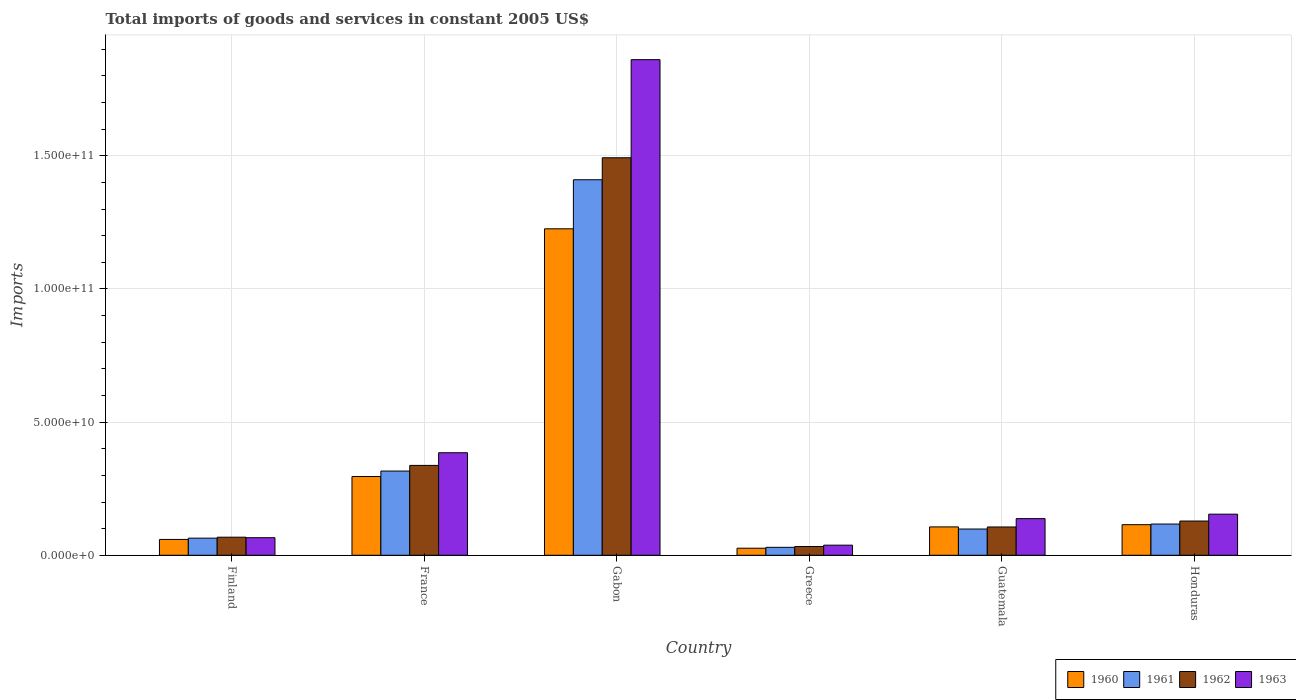How many bars are there on the 3rd tick from the right?
Keep it short and to the point. 4. What is the total imports of goods and services in 1961 in Finland?
Make the answer very short. 6.43e+09. Across all countries, what is the maximum total imports of goods and services in 1961?
Provide a succinct answer. 1.41e+11. Across all countries, what is the minimum total imports of goods and services in 1961?
Provide a succinct answer. 2.99e+09. In which country was the total imports of goods and services in 1961 maximum?
Give a very brief answer. Gabon. In which country was the total imports of goods and services in 1962 minimum?
Your answer should be compact. Greece. What is the total total imports of goods and services in 1960 in the graph?
Offer a terse response. 1.83e+11. What is the difference between the total imports of goods and services in 1963 in France and that in Honduras?
Ensure brevity in your answer.  2.31e+1. What is the difference between the total imports of goods and services in 1962 in Honduras and the total imports of goods and services in 1961 in France?
Your answer should be compact. -1.88e+1. What is the average total imports of goods and services in 1960 per country?
Make the answer very short. 3.05e+1. What is the difference between the total imports of goods and services of/in 1960 and total imports of goods and services of/in 1962 in Gabon?
Provide a short and direct response. -2.67e+1. In how many countries, is the total imports of goods and services in 1960 greater than 90000000000 US$?
Make the answer very short. 1. What is the ratio of the total imports of goods and services in 1962 in Guatemala to that in Honduras?
Ensure brevity in your answer.  0.83. Is the difference between the total imports of goods and services in 1960 in Gabon and Honduras greater than the difference between the total imports of goods and services in 1962 in Gabon and Honduras?
Offer a terse response. No. What is the difference between the highest and the second highest total imports of goods and services in 1963?
Offer a terse response. -2.31e+1. What is the difference between the highest and the lowest total imports of goods and services in 1960?
Give a very brief answer. 1.20e+11. In how many countries, is the total imports of goods and services in 1960 greater than the average total imports of goods and services in 1960 taken over all countries?
Ensure brevity in your answer.  1. Is the sum of the total imports of goods and services in 1961 in France and Honduras greater than the maximum total imports of goods and services in 1962 across all countries?
Provide a succinct answer. No. What does the 4th bar from the right in Guatemala represents?
Give a very brief answer. 1960. Is it the case that in every country, the sum of the total imports of goods and services in 1962 and total imports of goods and services in 1960 is greater than the total imports of goods and services in 1961?
Offer a terse response. Yes. What is the difference between two consecutive major ticks on the Y-axis?
Offer a very short reply. 5.00e+1. Are the values on the major ticks of Y-axis written in scientific E-notation?
Keep it short and to the point. Yes. Does the graph contain grids?
Your answer should be very brief. Yes. How many legend labels are there?
Your answer should be compact. 4. How are the legend labels stacked?
Provide a short and direct response. Horizontal. What is the title of the graph?
Your answer should be very brief. Total imports of goods and services in constant 2005 US$. What is the label or title of the X-axis?
Make the answer very short. Country. What is the label or title of the Y-axis?
Your answer should be very brief. Imports. What is the Imports in 1960 in Finland?
Ensure brevity in your answer.  5.95e+09. What is the Imports in 1961 in Finland?
Keep it short and to the point. 6.43e+09. What is the Imports of 1962 in Finland?
Provide a short and direct response. 6.79e+09. What is the Imports in 1963 in Finland?
Your answer should be very brief. 6.60e+09. What is the Imports in 1960 in France?
Keep it short and to the point. 2.96e+1. What is the Imports of 1961 in France?
Keep it short and to the point. 3.16e+1. What is the Imports of 1962 in France?
Provide a short and direct response. 3.37e+1. What is the Imports in 1963 in France?
Offer a very short reply. 3.85e+1. What is the Imports in 1960 in Gabon?
Your response must be concise. 1.23e+11. What is the Imports of 1961 in Gabon?
Provide a short and direct response. 1.41e+11. What is the Imports in 1962 in Gabon?
Offer a very short reply. 1.49e+11. What is the Imports of 1963 in Gabon?
Ensure brevity in your answer.  1.86e+11. What is the Imports of 1960 in Greece?
Offer a very short reply. 2.65e+09. What is the Imports in 1961 in Greece?
Your answer should be very brief. 2.99e+09. What is the Imports in 1962 in Greece?
Provide a short and direct response. 3.29e+09. What is the Imports of 1963 in Greece?
Ensure brevity in your answer.  3.80e+09. What is the Imports of 1960 in Guatemala?
Your answer should be very brief. 1.07e+1. What is the Imports of 1961 in Guatemala?
Make the answer very short. 9.86e+09. What is the Imports of 1962 in Guatemala?
Provide a succinct answer. 1.06e+1. What is the Imports of 1963 in Guatemala?
Offer a terse response. 1.38e+1. What is the Imports of 1960 in Honduras?
Ensure brevity in your answer.  1.15e+1. What is the Imports in 1961 in Honduras?
Ensure brevity in your answer.  1.17e+1. What is the Imports of 1962 in Honduras?
Offer a very short reply. 1.29e+1. What is the Imports in 1963 in Honduras?
Make the answer very short. 1.54e+1. Across all countries, what is the maximum Imports of 1960?
Your response must be concise. 1.23e+11. Across all countries, what is the maximum Imports of 1961?
Offer a terse response. 1.41e+11. Across all countries, what is the maximum Imports in 1962?
Give a very brief answer. 1.49e+11. Across all countries, what is the maximum Imports in 1963?
Make the answer very short. 1.86e+11. Across all countries, what is the minimum Imports in 1960?
Offer a very short reply. 2.65e+09. Across all countries, what is the minimum Imports in 1961?
Your answer should be compact. 2.99e+09. Across all countries, what is the minimum Imports of 1962?
Offer a terse response. 3.29e+09. Across all countries, what is the minimum Imports in 1963?
Provide a short and direct response. 3.80e+09. What is the total Imports of 1960 in the graph?
Provide a succinct answer. 1.83e+11. What is the total Imports of 1961 in the graph?
Offer a terse response. 2.04e+11. What is the total Imports in 1962 in the graph?
Your answer should be compact. 2.17e+11. What is the total Imports of 1963 in the graph?
Offer a terse response. 2.64e+11. What is the difference between the Imports in 1960 in Finland and that in France?
Your answer should be very brief. -2.36e+1. What is the difference between the Imports of 1961 in Finland and that in France?
Give a very brief answer. -2.52e+1. What is the difference between the Imports of 1962 in Finland and that in France?
Keep it short and to the point. -2.70e+1. What is the difference between the Imports of 1963 in Finland and that in France?
Provide a short and direct response. -3.19e+1. What is the difference between the Imports of 1960 in Finland and that in Gabon?
Offer a terse response. -1.17e+11. What is the difference between the Imports of 1961 in Finland and that in Gabon?
Your answer should be very brief. -1.35e+11. What is the difference between the Imports in 1962 in Finland and that in Gabon?
Your answer should be very brief. -1.42e+11. What is the difference between the Imports of 1963 in Finland and that in Gabon?
Provide a short and direct response. -1.79e+11. What is the difference between the Imports in 1960 in Finland and that in Greece?
Offer a terse response. 3.30e+09. What is the difference between the Imports of 1961 in Finland and that in Greece?
Offer a terse response. 3.44e+09. What is the difference between the Imports of 1962 in Finland and that in Greece?
Ensure brevity in your answer.  3.50e+09. What is the difference between the Imports in 1963 in Finland and that in Greece?
Make the answer very short. 2.80e+09. What is the difference between the Imports of 1960 in Finland and that in Guatemala?
Your answer should be very brief. -4.70e+09. What is the difference between the Imports of 1961 in Finland and that in Guatemala?
Give a very brief answer. -3.43e+09. What is the difference between the Imports of 1962 in Finland and that in Guatemala?
Make the answer very short. -3.84e+09. What is the difference between the Imports of 1963 in Finland and that in Guatemala?
Keep it short and to the point. -7.16e+09. What is the difference between the Imports in 1960 in Finland and that in Honduras?
Provide a succinct answer. -5.54e+09. What is the difference between the Imports of 1961 in Finland and that in Honduras?
Provide a succinct answer. -5.30e+09. What is the difference between the Imports of 1962 in Finland and that in Honduras?
Make the answer very short. -6.06e+09. What is the difference between the Imports in 1963 in Finland and that in Honduras?
Offer a very short reply. -8.84e+09. What is the difference between the Imports of 1960 in France and that in Gabon?
Keep it short and to the point. -9.30e+1. What is the difference between the Imports in 1961 in France and that in Gabon?
Make the answer very short. -1.09e+11. What is the difference between the Imports of 1962 in France and that in Gabon?
Make the answer very short. -1.16e+11. What is the difference between the Imports in 1963 in France and that in Gabon?
Offer a very short reply. -1.48e+11. What is the difference between the Imports of 1960 in France and that in Greece?
Offer a terse response. 2.69e+1. What is the difference between the Imports of 1961 in France and that in Greece?
Ensure brevity in your answer.  2.86e+1. What is the difference between the Imports in 1962 in France and that in Greece?
Your response must be concise. 3.05e+1. What is the difference between the Imports of 1963 in France and that in Greece?
Offer a very short reply. 3.47e+1. What is the difference between the Imports in 1960 in France and that in Guatemala?
Ensure brevity in your answer.  1.89e+1. What is the difference between the Imports of 1961 in France and that in Guatemala?
Keep it short and to the point. 2.18e+1. What is the difference between the Imports in 1962 in France and that in Guatemala?
Keep it short and to the point. 2.31e+1. What is the difference between the Imports of 1963 in France and that in Guatemala?
Your answer should be very brief. 2.47e+1. What is the difference between the Imports in 1960 in France and that in Honduras?
Your response must be concise. 1.81e+1. What is the difference between the Imports of 1961 in France and that in Honduras?
Provide a short and direct response. 1.99e+1. What is the difference between the Imports of 1962 in France and that in Honduras?
Give a very brief answer. 2.09e+1. What is the difference between the Imports in 1963 in France and that in Honduras?
Provide a succinct answer. 2.31e+1. What is the difference between the Imports of 1960 in Gabon and that in Greece?
Give a very brief answer. 1.20e+11. What is the difference between the Imports of 1961 in Gabon and that in Greece?
Provide a short and direct response. 1.38e+11. What is the difference between the Imports of 1962 in Gabon and that in Greece?
Ensure brevity in your answer.  1.46e+11. What is the difference between the Imports in 1963 in Gabon and that in Greece?
Provide a succinct answer. 1.82e+11. What is the difference between the Imports of 1960 in Gabon and that in Guatemala?
Your response must be concise. 1.12e+11. What is the difference between the Imports of 1961 in Gabon and that in Guatemala?
Your response must be concise. 1.31e+11. What is the difference between the Imports in 1962 in Gabon and that in Guatemala?
Provide a short and direct response. 1.39e+11. What is the difference between the Imports in 1963 in Gabon and that in Guatemala?
Offer a terse response. 1.72e+11. What is the difference between the Imports of 1960 in Gabon and that in Honduras?
Your answer should be compact. 1.11e+11. What is the difference between the Imports in 1961 in Gabon and that in Honduras?
Make the answer very short. 1.29e+11. What is the difference between the Imports in 1962 in Gabon and that in Honduras?
Give a very brief answer. 1.36e+11. What is the difference between the Imports of 1963 in Gabon and that in Honduras?
Give a very brief answer. 1.71e+11. What is the difference between the Imports in 1960 in Greece and that in Guatemala?
Offer a very short reply. -8.00e+09. What is the difference between the Imports of 1961 in Greece and that in Guatemala?
Make the answer very short. -6.87e+09. What is the difference between the Imports of 1962 in Greece and that in Guatemala?
Provide a succinct answer. -7.34e+09. What is the difference between the Imports of 1963 in Greece and that in Guatemala?
Your response must be concise. -9.96e+09. What is the difference between the Imports of 1960 in Greece and that in Honduras?
Give a very brief answer. -8.83e+09. What is the difference between the Imports in 1961 in Greece and that in Honduras?
Ensure brevity in your answer.  -8.74e+09. What is the difference between the Imports in 1962 in Greece and that in Honduras?
Your answer should be very brief. -9.56e+09. What is the difference between the Imports in 1963 in Greece and that in Honduras?
Offer a terse response. -1.16e+1. What is the difference between the Imports in 1960 in Guatemala and that in Honduras?
Your answer should be very brief. -8.33e+08. What is the difference between the Imports of 1961 in Guatemala and that in Honduras?
Offer a terse response. -1.87e+09. What is the difference between the Imports in 1962 in Guatemala and that in Honduras?
Ensure brevity in your answer.  -2.23e+09. What is the difference between the Imports in 1963 in Guatemala and that in Honduras?
Ensure brevity in your answer.  -1.68e+09. What is the difference between the Imports of 1960 in Finland and the Imports of 1961 in France?
Your answer should be compact. -2.57e+1. What is the difference between the Imports in 1960 in Finland and the Imports in 1962 in France?
Your answer should be very brief. -2.78e+1. What is the difference between the Imports of 1960 in Finland and the Imports of 1963 in France?
Keep it short and to the point. -3.25e+1. What is the difference between the Imports of 1961 in Finland and the Imports of 1962 in France?
Ensure brevity in your answer.  -2.73e+1. What is the difference between the Imports in 1961 in Finland and the Imports in 1963 in France?
Provide a succinct answer. -3.21e+1. What is the difference between the Imports of 1962 in Finland and the Imports of 1963 in France?
Provide a short and direct response. -3.17e+1. What is the difference between the Imports of 1960 in Finland and the Imports of 1961 in Gabon?
Give a very brief answer. -1.35e+11. What is the difference between the Imports in 1960 in Finland and the Imports in 1962 in Gabon?
Offer a terse response. -1.43e+11. What is the difference between the Imports in 1960 in Finland and the Imports in 1963 in Gabon?
Your answer should be compact. -1.80e+11. What is the difference between the Imports of 1961 in Finland and the Imports of 1962 in Gabon?
Give a very brief answer. -1.43e+11. What is the difference between the Imports in 1961 in Finland and the Imports in 1963 in Gabon?
Give a very brief answer. -1.80e+11. What is the difference between the Imports in 1962 in Finland and the Imports in 1963 in Gabon?
Your response must be concise. -1.79e+11. What is the difference between the Imports of 1960 in Finland and the Imports of 1961 in Greece?
Your response must be concise. 2.96e+09. What is the difference between the Imports in 1960 in Finland and the Imports in 1962 in Greece?
Give a very brief answer. 2.66e+09. What is the difference between the Imports of 1960 in Finland and the Imports of 1963 in Greece?
Provide a short and direct response. 2.15e+09. What is the difference between the Imports of 1961 in Finland and the Imports of 1962 in Greece?
Your response must be concise. 3.14e+09. What is the difference between the Imports of 1961 in Finland and the Imports of 1963 in Greece?
Ensure brevity in your answer.  2.63e+09. What is the difference between the Imports in 1962 in Finland and the Imports in 1963 in Greece?
Your response must be concise. 2.99e+09. What is the difference between the Imports of 1960 in Finland and the Imports of 1961 in Guatemala?
Your answer should be compact. -3.91e+09. What is the difference between the Imports in 1960 in Finland and the Imports in 1962 in Guatemala?
Provide a succinct answer. -4.68e+09. What is the difference between the Imports of 1960 in Finland and the Imports of 1963 in Guatemala?
Make the answer very short. -7.81e+09. What is the difference between the Imports of 1961 in Finland and the Imports of 1962 in Guatemala?
Your answer should be very brief. -4.20e+09. What is the difference between the Imports in 1961 in Finland and the Imports in 1963 in Guatemala?
Offer a terse response. -7.33e+09. What is the difference between the Imports of 1962 in Finland and the Imports of 1963 in Guatemala?
Your response must be concise. -6.97e+09. What is the difference between the Imports in 1960 in Finland and the Imports in 1961 in Honduras?
Give a very brief answer. -5.78e+09. What is the difference between the Imports in 1960 in Finland and the Imports in 1962 in Honduras?
Your answer should be compact. -6.90e+09. What is the difference between the Imports of 1960 in Finland and the Imports of 1963 in Honduras?
Your answer should be very brief. -9.49e+09. What is the difference between the Imports in 1961 in Finland and the Imports in 1962 in Honduras?
Keep it short and to the point. -6.42e+09. What is the difference between the Imports in 1961 in Finland and the Imports in 1963 in Honduras?
Provide a short and direct response. -9.01e+09. What is the difference between the Imports in 1962 in Finland and the Imports in 1963 in Honduras?
Ensure brevity in your answer.  -8.65e+09. What is the difference between the Imports of 1960 in France and the Imports of 1961 in Gabon?
Provide a succinct answer. -1.11e+11. What is the difference between the Imports of 1960 in France and the Imports of 1962 in Gabon?
Give a very brief answer. -1.20e+11. What is the difference between the Imports in 1960 in France and the Imports in 1963 in Gabon?
Provide a succinct answer. -1.57e+11. What is the difference between the Imports of 1961 in France and the Imports of 1962 in Gabon?
Keep it short and to the point. -1.18e+11. What is the difference between the Imports in 1961 in France and the Imports in 1963 in Gabon?
Keep it short and to the point. -1.54e+11. What is the difference between the Imports of 1962 in France and the Imports of 1963 in Gabon?
Your answer should be compact. -1.52e+11. What is the difference between the Imports in 1960 in France and the Imports in 1961 in Greece?
Your response must be concise. 2.66e+1. What is the difference between the Imports of 1960 in France and the Imports of 1962 in Greece?
Your response must be concise. 2.63e+1. What is the difference between the Imports of 1960 in France and the Imports of 1963 in Greece?
Offer a very short reply. 2.58e+1. What is the difference between the Imports of 1961 in France and the Imports of 1962 in Greece?
Your answer should be very brief. 2.83e+1. What is the difference between the Imports of 1961 in France and the Imports of 1963 in Greece?
Provide a succinct answer. 2.78e+1. What is the difference between the Imports in 1962 in France and the Imports in 1963 in Greece?
Ensure brevity in your answer.  2.99e+1. What is the difference between the Imports of 1960 in France and the Imports of 1961 in Guatemala?
Your answer should be compact. 1.97e+1. What is the difference between the Imports in 1960 in France and the Imports in 1962 in Guatemala?
Your answer should be very brief. 1.89e+1. What is the difference between the Imports in 1960 in France and the Imports in 1963 in Guatemala?
Give a very brief answer. 1.58e+1. What is the difference between the Imports in 1961 in France and the Imports in 1962 in Guatemala?
Make the answer very short. 2.10e+1. What is the difference between the Imports in 1961 in France and the Imports in 1963 in Guatemala?
Offer a terse response. 1.79e+1. What is the difference between the Imports of 1962 in France and the Imports of 1963 in Guatemala?
Your response must be concise. 2.00e+1. What is the difference between the Imports of 1960 in France and the Imports of 1961 in Honduras?
Give a very brief answer. 1.78e+1. What is the difference between the Imports of 1960 in France and the Imports of 1962 in Honduras?
Keep it short and to the point. 1.67e+1. What is the difference between the Imports of 1960 in France and the Imports of 1963 in Honduras?
Your answer should be compact. 1.41e+1. What is the difference between the Imports in 1961 in France and the Imports in 1962 in Honduras?
Your answer should be compact. 1.88e+1. What is the difference between the Imports in 1961 in France and the Imports in 1963 in Honduras?
Your answer should be very brief. 1.62e+1. What is the difference between the Imports of 1962 in France and the Imports of 1963 in Honduras?
Your answer should be compact. 1.83e+1. What is the difference between the Imports of 1960 in Gabon and the Imports of 1961 in Greece?
Your response must be concise. 1.20e+11. What is the difference between the Imports of 1960 in Gabon and the Imports of 1962 in Greece?
Make the answer very short. 1.19e+11. What is the difference between the Imports of 1960 in Gabon and the Imports of 1963 in Greece?
Give a very brief answer. 1.19e+11. What is the difference between the Imports of 1961 in Gabon and the Imports of 1962 in Greece?
Offer a very short reply. 1.38e+11. What is the difference between the Imports in 1961 in Gabon and the Imports in 1963 in Greece?
Ensure brevity in your answer.  1.37e+11. What is the difference between the Imports of 1962 in Gabon and the Imports of 1963 in Greece?
Provide a succinct answer. 1.45e+11. What is the difference between the Imports of 1960 in Gabon and the Imports of 1961 in Guatemala?
Provide a short and direct response. 1.13e+11. What is the difference between the Imports of 1960 in Gabon and the Imports of 1962 in Guatemala?
Your answer should be very brief. 1.12e+11. What is the difference between the Imports of 1960 in Gabon and the Imports of 1963 in Guatemala?
Offer a terse response. 1.09e+11. What is the difference between the Imports in 1961 in Gabon and the Imports in 1962 in Guatemala?
Your response must be concise. 1.30e+11. What is the difference between the Imports in 1961 in Gabon and the Imports in 1963 in Guatemala?
Your response must be concise. 1.27e+11. What is the difference between the Imports in 1962 in Gabon and the Imports in 1963 in Guatemala?
Provide a succinct answer. 1.35e+11. What is the difference between the Imports in 1960 in Gabon and the Imports in 1961 in Honduras?
Provide a succinct answer. 1.11e+11. What is the difference between the Imports of 1960 in Gabon and the Imports of 1962 in Honduras?
Provide a short and direct response. 1.10e+11. What is the difference between the Imports in 1960 in Gabon and the Imports in 1963 in Honduras?
Your answer should be compact. 1.07e+11. What is the difference between the Imports in 1961 in Gabon and the Imports in 1962 in Honduras?
Offer a very short reply. 1.28e+11. What is the difference between the Imports in 1961 in Gabon and the Imports in 1963 in Honduras?
Provide a short and direct response. 1.26e+11. What is the difference between the Imports in 1962 in Gabon and the Imports in 1963 in Honduras?
Keep it short and to the point. 1.34e+11. What is the difference between the Imports of 1960 in Greece and the Imports of 1961 in Guatemala?
Provide a succinct answer. -7.21e+09. What is the difference between the Imports of 1960 in Greece and the Imports of 1962 in Guatemala?
Offer a terse response. -7.97e+09. What is the difference between the Imports in 1960 in Greece and the Imports in 1963 in Guatemala?
Make the answer very short. -1.11e+1. What is the difference between the Imports of 1961 in Greece and the Imports of 1962 in Guatemala?
Offer a terse response. -7.64e+09. What is the difference between the Imports of 1961 in Greece and the Imports of 1963 in Guatemala?
Your response must be concise. -1.08e+1. What is the difference between the Imports of 1962 in Greece and the Imports of 1963 in Guatemala?
Give a very brief answer. -1.05e+1. What is the difference between the Imports in 1960 in Greece and the Imports in 1961 in Honduras?
Provide a succinct answer. -9.08e+09. What is the difference between the Imports of 1960 in Greece and the Imports of 1962 in Honduras?
Give a very brief answer. -1.02e+1. What is the difference between the Imports in 1960 in Greece and the Imports in 1963 in Honduras?
Offer a very short reply. -1.28e+1. What is the difference between the Imports in 1961 in Greece and the Imports in 1962 in Honduras?
Make the answer very short. -9.86e+09. What is the difference between the Imports in 1961 in Greece and the Imports in 1963 in Honduras?
Provide a succinct answer. -1.24e+1. What is the difference between the Imports of 1962 in Greece and the Imports of 1963 in Honduras?
Provide a short and direct response. -1.21e+1. What is the difference between the Imports in 1960 in Guatemala and the Imports in 1961 in Honduras?
Your response must be concise. -1.08e+09. What is the difference between the Imports of 1960 in Guatemala and the Imports of 1962 in Honduras?
Your answer should be compact. -2.20e+09. What is the difference between the Imports of 1960 in Guatemala and the Imports of 1963 in Honduras?
Provide a succinct answer. -4.78e+09. What is the difference between the Imports in 1961 in Guatemala and the Imports in 1962 in Honduras?
Give a very brief answer. -2.99e+09. What is the difference between the Imports of 1961 in Guatemala and the Imports of 1963 in Honduras?
Your answer should be very brief. -5.58e+09. What is the difference between the Imports in 1962 in Guatemala and the Imports in 1963 in Honduras?
Your answer should be very brief. -4.81e+09. What is the average Imports in 1960 per country?
Your answer should be compact. 3.05e+1. What is the average Imports of 1961 per country?
Offer a terse response. 3.39e+1. What is the average Imports in 1962 per country?
Ensure brevity in your answer.  3.61e+1. What is the average Imports of 1963 per country?
Your response must be concise. 4.40e+1. What is the difference between the Imports of 1960 and Imports of 1961 in Finland?
Offer a terse response. -4.80e+08. What is the difference between the Imports in 1960 and Imports in 1962 in Finland?
Make the answer very short. -8.40e+08. What is the difference between the Imports in 1960 and Imports in 1963 in Finland?
Offer a terse response. -6.52e+08. What is the difference between the Imports of 1961 and Imports of 1962 in Finland?
Give a very brief answer. -3.61e+08. What is the difference between the Imports of 1961 and Imports of 1963 in Finland?
Ensure brevity in your answer.  -1.72e+08. What is the difference between the Imports of 1962 and Imports of 1963 in Finland?
Offer a terse response. 1.89e+08. What is the difference between the Imports in 1960 and Imports in 1961 in France?
Keep it short and to the point. -2.05e+09. What is the difference between the Imports in 1960 and Imports in 1962 in France?
Make the answer very short. -4.17e+09. What is the difference between the Imports of 1960 and Imports of 1963 in France?
Offer a terse response. -8.93e+09. What is the difference between the Imports of 1961 and Imports of 1962 in France?
Keep it short and to the point. -2.12e+09. What is the difference between the Imports in 1961 and Imports in 1963 in France?
Provide a succinct answer. -6.88e+09. What is the difference between the Imports in 1962 and Imports in 1963 in France?
Offer a terse response. -4.75e+09. What is the difference between the Imports of 1960 and Imports of 1961 in Gabon?
Make the answer very short. -1.84e+1. What is the difference between the Imports in 1960 and Imports in 1962 in Gabon?
Provide a short and direct response. -2.67e+1. What is the difference between the Imports in 1960 and Imports in 1963 in Gabon?
Your response must be concise. -6.35e+1. What is the difference between the Imports of 1961 and Imports of 1962 in Gabon?
Your answer should be compact. -8.26e+09. What is the difference between the Imports of 1961 and Imports of 1963 in Gabon?
Provide a short and direct response. -4.51e+1. What is the difference between the Imports of 1962 and Imports of 1963 in Gabon?
Provide a short and direct response. -3.68e+1. What is the difference between the Imports in 1960 and Imports in 1961 in Greece?
Your answer should be compact. -3.37e+08. What is the difference between the Imports in 1960 and Imports in 1962 in Greece?
Make the answer very short. -6.39e+08. What is the difference between the Imports of 1960 and Imports of 1963 in Greece?
Ensure brevity in your answer.  -1.15e+09. What is the difference between the Imports of 1961 and Imports of 1962 in Greece?
Your answer should be compact. -3.02e+08. What is the difference between the Imports of 1961 and Imports of 1963 in Greece?
Your answer should be compact. -8.09e+08. What is the difference between the Imports in 1962 and Imports in 1963 in Greece?
Your answer should be very brief. -5.06e+08. What is the difference between the Imports in 1960 and Imports in 1961 in Guatemala?
Ensure brevity in your answer.  7.93e+08. What is the difference between the Imports of 1960 and Imports of 1962 in Guatemala?
Make the answer very short. 2.58e+07. What is the difference between the Imports of 1960 and Imports of 1963 in Guatemala?
Offer a very short reply. -3.11e+09. What is the difference between the Imports in 1961 and Imports in 1962 in Guatemala?
Your response must be concise. -7.67e+08. What is the difference between the Imports of 1961 and Imports of 1963 in Guatemala?
Ensure brevity in your answer.  -3.90e+09. What is the difference between the Imports in 1962 and Imports in 1963 in Guatemala?
Your answer should be very brief. -3.13e+09. What is the difference between the Imports of 1960 and Imports of 1961 in Honduras?
Ensure brevity in your answer.  -2.44e+08. What is the difference between the Imports in 1960 and Imports in 1962 in Honduras?
Ensure brevity in your answer.  -1.37e+09. What is the difference between the Imports in 1960 and Imports in 1963 in Honduras?
Provide a succinct answer. -3.95e+09. What is the difference between the Imports of 1961 and Imports of 1962 in Honduras?
Keep it short and to the point. -1.12e+09. What is the difference between the Imports of 1961 and Imports of 1963 in Honduras?
Make the answer very short. -3.71e+09. What is the difference between the Imports of 1962 and Imports of 1963 in Honduras?
Provide a succinct answer. -2.58e+09. What is the ratio of the Imports in 1960 in Finland to that in France?
Give a very brief answer. 0.2. What is the ratio of the Imports of 1961 in Finland to that in France?
Offer a very short reply. 0.2. What is the ratio of the Imports in 1962 in Finland to that in France?
Ensure brevity in your answer.  0.2. What is the ratio of the Imports of 1963 in Finland to that in France?
Your answer should be very brief. 0.17. What is the ratio of the Imports in 1960 in Finland to that in Gabon?
Your answer should be very brief. 0.05. What is the ratio of the Imports in 1961 in Finland to that in Gabon?
Your response must be concise. 0.05. What is the ratio of the Imports of 1962 in Finland to that in Gabon?
Your answer should be compact. 0.05. What is the ratio of the Imports of 1963 in Finland to that in Gabon?
Provide a short and direct response. 0.04. What is the ratio of the Imports in 1960 in Finland to that in Greece?
Your answer should be compact. 2.24. What is the ratio of the Imports of 1961 in Finland to that in Greece?
Offer a terse response. 2.15. What is the ratio of the Imports of 1962 in Finland to that in Greece?
Ensure brevity in your answer.  2.06. What is the ratio of the Imports of 1963 in Finland to that in Greece?
Your answer should be compact. 1.74. What is the ratio of the Imports in 1960 in Finland to that in Guatemala?
Your answer should be very brief. 0.56. What is the ratio of the Imports of 1961 in Finland to that in Guatemala?
Provide a short and direct response. 0.65. What is the ratio of the Imports of 1962 in Finland to that in Guatemala?
Keep it short and to the point. 0.64. What is the ratio of the Imports in 1963 in Finland to that in Guatemala?
Offer a terse response. 0.48. What is the ratio of the Imports of 1960 in Finland to that in Honduras?
Your response must be concise. 0.52. What is the ratio of the Imports of 1961 in Finland to that in Honduras?
Ensure brevity in your answer.  0.55. What is the ratio of the Imports of 1962 in Finland to that in Honduras?
Offer a terse response. 0.53. What is the ratio of the Imports in 1963 in Finland to that in Honduras?
Offer a very short reply. 0.43. What is the ratio of the Imports in 1960 in France to that in Gabon?
Your response must be concise. 0.24. What is the ratio of the Imports in 1961 in France to that in Gabon?
Your answer should be very brief. 0.22. What is the ratio of the Imports in 1962 in France to that in Gabon?
Provide a succinct answer. 0.23. What is the ratio of the Imports in 1963 in France to that in Gabon?
Your response must be concise. 0.21. What is the ratio of the Imports of 1960 in France to that in Greece?
Keep it short and to the point. 11.15. What is the ratio of the Imports of 1961 in France to that in Greece?
Provide a short and direct response. 10.58. What is the ratio of the Imports in 1962 in France to that in Greece?
Offer a very short reply. 10.25. What is the ratio of the Imports in 1963 in France to that in Greece?
Provide a short and direct response. 10.14. What is the ratio of the Imports of 1960 in France to that in Guatemala?
Offer a very short reply. 2.78. What is the ratio of the Imports in 1961 in France to that in Guatemala?
Give a very brief answer. 3.21. What is the ratio of the Imports in 1962 in France to that in Guatemala?
Provide a succinct answer. 3.18. What is the ratio of the Imports in 1963 in France to that in Guatemala?
Your response must be concise. 2.8. What is the ratio of the Imports of 1960 in France to that in Honduras?
Keep it short and to the point. 2.57. What is the ratio of the Imports in 1961 in France to that in Honduras?
Offer a very short reply. 2.7. What is the ratio of the Imports of 1962 in France to that in Honduras?
Your response must be concise. 2.63. What is the ratio of the Imports of 1963 in France to that in Honduras?
Give a very brief answer. 2.49. What is the ratio of the Imports in 1960 in Gabon to that in Greece?
Provide a succinct answer. 46.22. What is the ratio of the Imports in 1961 in Gabon to that in Greece?
Provide a succinct answer. 47.18. What is the ratio of the Imports of 1962 in Gabon to that in Greece?
Make the answer very short. 45.35. What is the ratio of the Imports in 1963 in Gabon to that in Greece?
Your answer should be compact. 49. What is the ratio of the Imports in 1960 in Gabon to that in Guatemala?
Provide a succinct answer. 11.51. What is the ratio of the Imports in 1961 in Gabon to that in Guatemala?
Ensure brevity in your answer.  14.3. What is the ratio of the Imports in 1962 in Gabon to that in Guatemala?
Keep it short and to the point. 14.05. What is the ratio of the Imports of 1963 in Gabon to that in Guatemala?
Make the answer very short. 13.52. What is the ratio of the Imports in 1960 in Gabon to that in Honduras?
Provide a short and direct response. 10.67. What is the ratio of the Imports in 1961 in Gabon to that in Honduras?
Ensure brevity in your answer.  12.02. What is the ratio of the Imports of 1962 in Gabon to that in Honduras?
Ensure brevity in your answer.  11.61. What is the ratio of the Imports of 1963 in Gabon to that in Honduras?
Your answer should be very brief. 12.06. What is the ratio of the Imports of 1960 in Greece to that in Guatemala?
Provide a short and direct response. 0.25. What is the ratio of the Imports of 1961 in Greece to that in Guatemala?
Provide a short and direct response. 0.3. What is the ratio of the Imports of 1962 in Greece to that in Guatemala?
Provide a succinct answer. 0.31. What is the ratio of the Imports in 1963 in Greece to that in Guatemala?
Make the answer very short. 0.28. What is the ratio of the Imports of 1960 in Greece to that in Honduras?
Give a very brief answer. 0.23. What is the ratio of the Imports in 1961 in Greece to that in Honduras?
Offer a terse response. 0.25. What is the ratio of the Imports in 1962 in Greece to that in Honduras?
Your answer should be very brief. 0.26. What is the ratio of the Imports of 1963 in Greece to that in Honduras?
Offer a terse response. 0.25. What is the ratio of the Imports of 1960 in Guatemala to that in Honduras?
Give a very brief answer. 0.93. What is the ratio of the Imports of 1961 in Guatemala to that in Honduras?
Ensure brevity in your answer.  0.84. What is the ratio of the Imports of 1962 in Guatemala to that in Honduras?
Your answer should be compact. 0.83. What is the ratio of the Imports in 1963 in Guatemala to that in Honduras?
Give a very brief answer. 0.89. What is the difference between the highest and the second highest Imports in 1960?
Your answer should be very brief. 9.30e+1. What is the difference between the highest and the second highest Imports of 1961?
Provide a succinct answer. 1.09e+11. What is the difference between the highest and the second highest Imports of 1962?
Your answer should be very brief. 1.16e+11. What is the difference between the highest and the second highest Imports in 1963?
Your answer should be compact. 1.48e+11. What is the difference between the highest and the lowest Imports of 1960?
Ensure brevity in your answer.  1.20e+11. What is the difference between the highest and the lowest Imports in 1961?
Provide a succinct answer. 1.38e+11. What is the difference between the highest and the lowest Imports in 1962?
Keep it short and to the point. 1.46e+11. What is the difference between the highest and the lowest Imports in 1963?
Your answer should be very brief. 1.82e+11. 